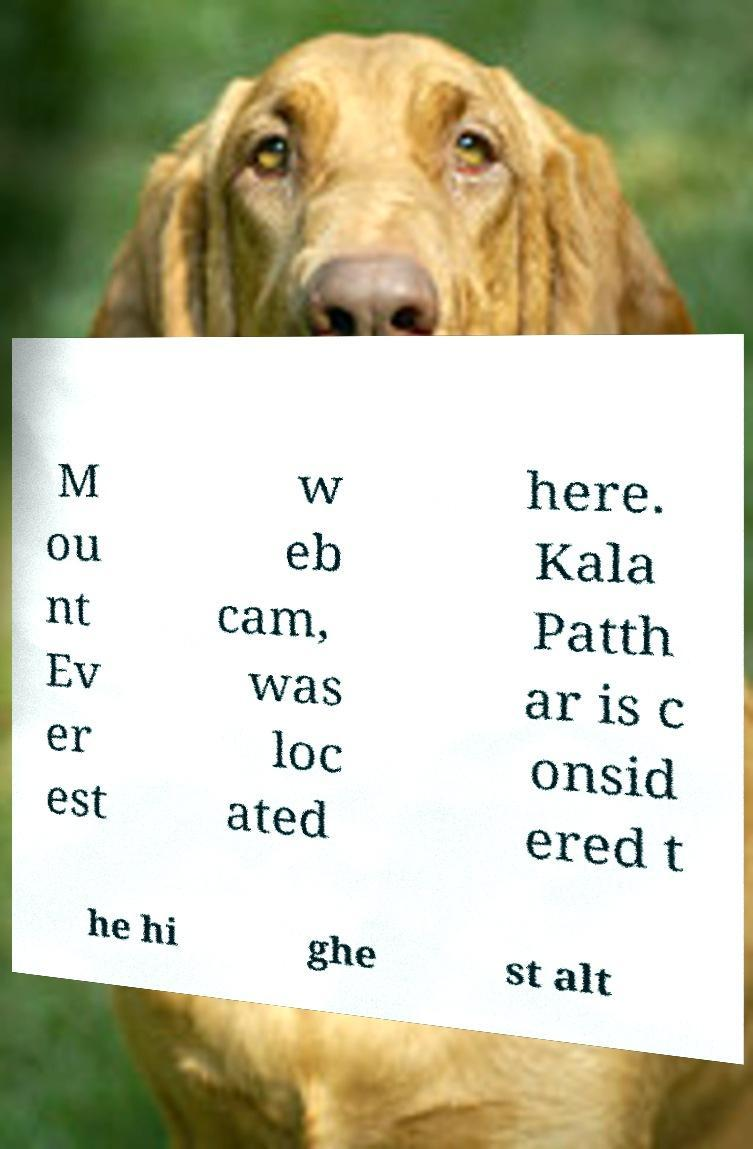Could you extract and type out the text from this image? M ou nt Ev er est w eb cam, was loc ated here. Kala Patth ar is c onsid ered t he hi ghe st alt 